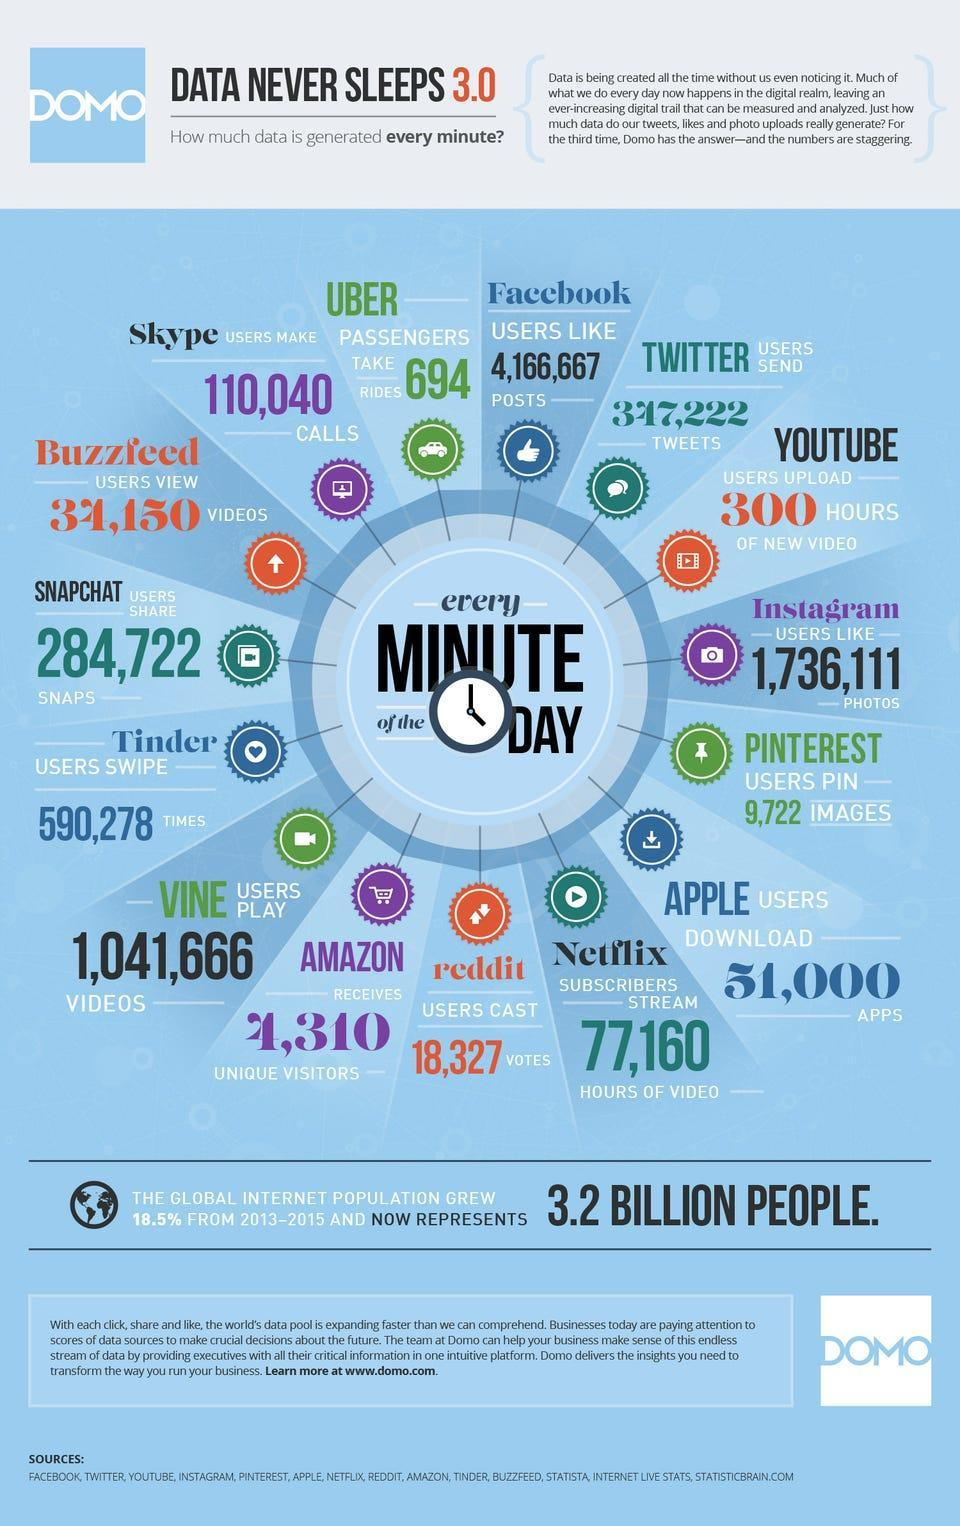How many social media applications are given red color code?
Answer the question with a short phrase. 3 How much data is being created with Twitter in every minute? 347,222 tweets What is the background color of the Facebook logo- red, blue, green, yellow? blue How many new applications are installed by Apple Users in a minute? 51,000 apps How many posts are given likes in Instagram in a minute? 1,736,111 How many pins occur for photos in Pinterest in a minute? 9,722 How much data is getting uploaded into YouTube in a minute? 300 hours of new video How many different users checks Amazon website in a minute? 4,310 How many user actions comes in Tinder in a minute? 590,278 times How much is the total length of the programs watched in Netflix in a minute? 77,160 hours of video 